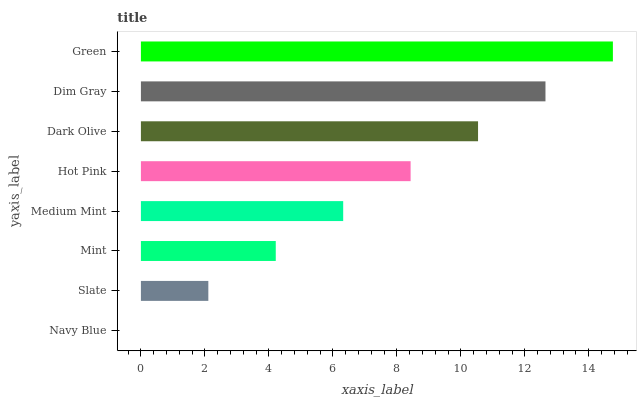Is Navy Blue the minimum?
Answer yes or no. Yes. Is Green the maximum?
Answer yes or no. Yes. Is Slate the minimum?
Answer yes or no. No. Is Slate the maximum?
Answer yes or no. No. Is Slate greater than Navy Blue?
Answer yes or no. Yes. Is Navy Blue less than Slate?
Answer yes or no. Yes. Is Navy Blue greater than Slate?
Answer yes or no. No. Is Slate less than Navy Blue?
Answer yes or no. No. Is Hot Pink the high median?
Answer yes or no. Yes. Is Medium Mint the low median?
Answer yes or no. Yes. Is Slate the high median?
Answer yes or no. No. Is Green the low median?
Answer yes or no. No. 